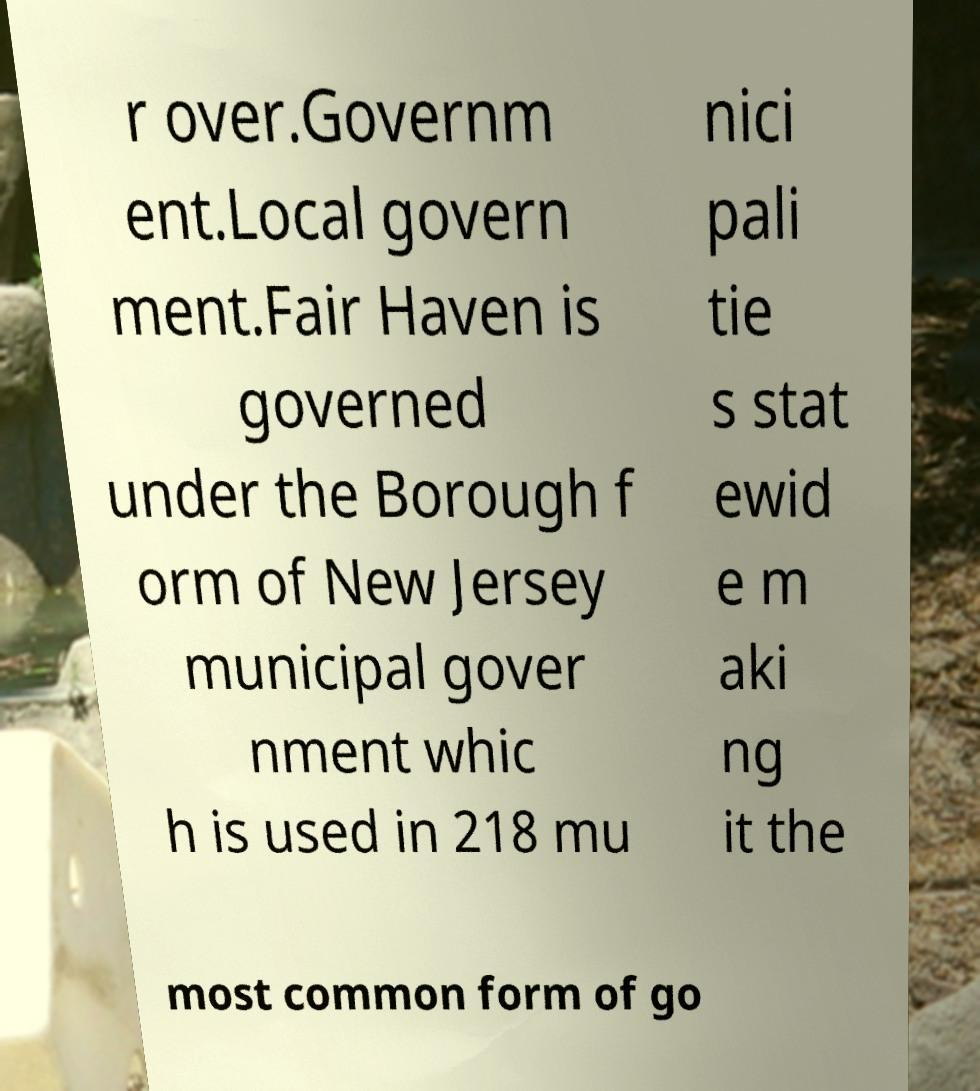Please identify and transcribe the text found in this image. r over.Governm ent.Local govern ment.Fair Haven is governed under the Borough f orm of New Jersey municipal gover nment whic h is used in 218 mu nici pali tie s stat ewid e m aki ng it the most common form of go 